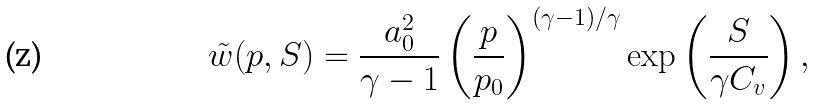<formula> <loc_0><loc_0><loc_500><loc_500>\tilde { w } ( p , S ) = \frac { a _ { 0 } ^ { 2 } } { \gamma - 1 } \left ( \frac { p } { p _ { 0 } } \right ) ^ { ( \gamma - 1 ) / \gamma } \exp \left ( \frac { S } { \gamma C _ { v } } \right ) ,</formula> 